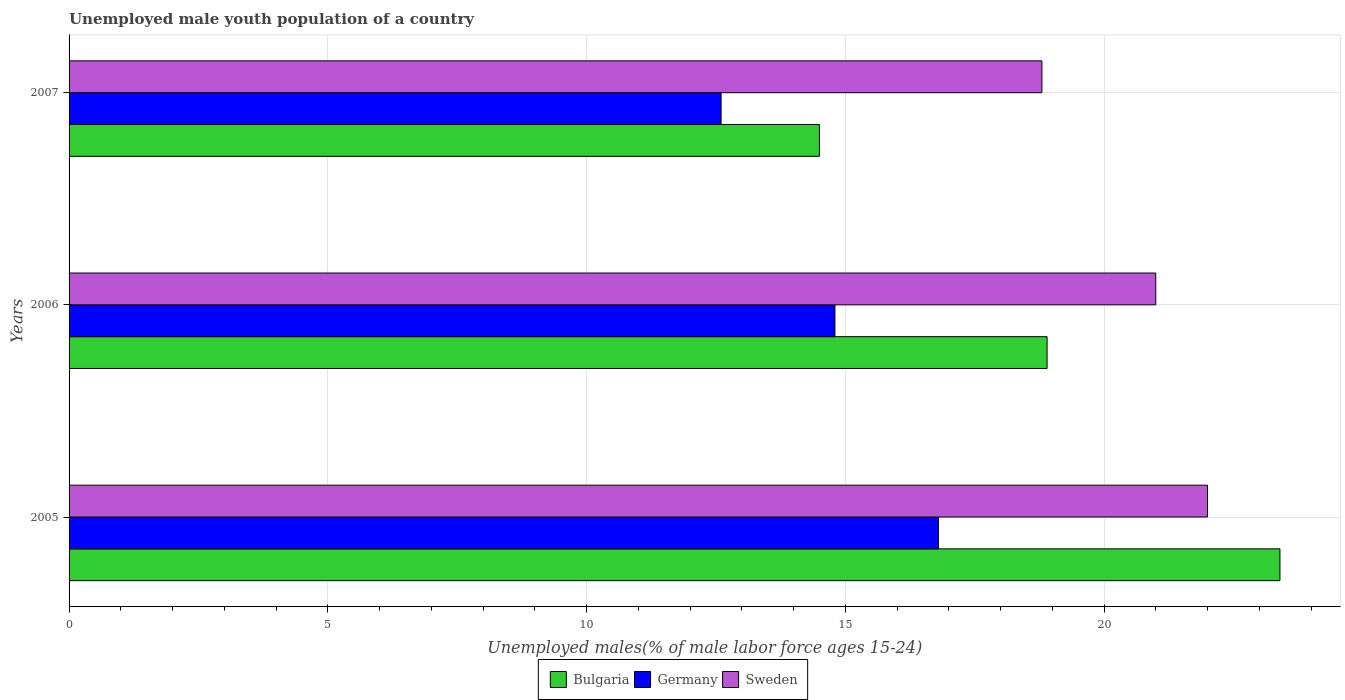How many different coloured bars are there?
Give a very brief answer. 3. How many bars are there on the 1st tick from the bottom?
Your answer should be very brief. 3. What is the label of the 2nd group of bars from the top?
Your answer should be compact. 2006. What is the percentage of unemployed male youth population in Sweden in 2005?
Give a very brief answer. 22. Across all years, what is the maximum percentage of unemployed male youth population in Bulgaria?
Keep it short and to the point. 23.4. Across all years, what is the minimum percentage of unemployed male youth population in Sweden?
Your response must be concise. 18.8. In which year was the percentage of unemployed male youth population in Bulgaria maximum?
Provide a short and direct response. 2005. What is the total percentage of unemployed male youth population in Sweden in the graph?
Keep it short and to the point. 61.8. What is the difference between the percentage of unemployed male youth population in Germany in 2006 and that in 2007?
Provide a succinct answer. 2.2. What is the difference between the percentage of unemployed male youth population in Germany in 2005 and the percentage of unemployed male youth population in Sweden in 2007?
Your answer should be very brief. -2. What is the average percentage of unemployed male youth population in Germany per year?
Offer a terse response. 14.73. In the year 2005, what is the difference between the percentage of unemployed male youth population in Sweden and percentage of unemployed male youth population in Germany?
Provide a short and direct response. 5.2. What is the ratio of the percentage of unemployed male youth population in Sweden in 2006 to that in 2007?
Give a very brief answer. 1.12. Is the difference between the percentage of unemployed male youth population in Sweden in 2005 and 2007 greater than the difference between the percentage of unemployed male youth population in Germany in 2005 and 2007?
Offer a terse response. No. What is the difference between the highest and the second highest percentage of unemployed male youth population in Sweden?
Give a very brief answer. 1. What is the difference between the highest and the lowest percentage of unemployed male youth population in Bulgaria?
Ensure brevity in your answer.  8.9. What does the 3rd bar from the top in 2007 represents?
Provide a succinct answer. Bulgaria. Is it the case that in every year, the sum of the percentage of unemployed male youth population in Germany and percentage of unemployed male youth population in Sweden is greater than the percentage of unemployed male youth population in Bulgaria?
Your response must be concise. Yes. How many bars are there?
Provide a short and direct response. 9. Are all the bars in the graph horizontal?
Keep it short and to the point. Yes. What is the difference between two consecutive major ticks on the X-axis?
Your response must be concise. 5. Does the graph contain any zero values?
Your answer should be compact. No. What is the title of the graph?
Ensure brevity in your answer.  Unemployed male youth population of a country. Does "Hungary" appear as one of the legend labels in the graph?
Ensure brevity in your answer.  No. What is the label or title of the X-axis?
Offer a terse response. Unemployed males(% of male labor force ages 15-24). What is the Unemployed males(% of male labor force ages 15-24) in Bulgaria in 2005?
Keep it short and to the point. 23.4. What is the Unemployed males(% of male labor force ages 15-24) in Germany in 2005?
Provide a succinct answer. 16.8. What is the Unemployed males(% of male labor force ages 15-24) of Bulgaria in 2006?
Provide a short and direct response. 18.9. What is the Unemployed males(% of male labor force ages 15-24) in Germany in 2006?
Offer a terse response. 14.8. What is the Unemployed males(% of male labor force ages 15-24) in Bulgaria in 2007?
Offer a terse response. 14.5. What is the Unemployed males(% of male labor force ages 15-24) in Germany in 2007?
Give a very brief answer. 12.6. What is the Unemployed males(% of male labor force ages 15-24) of Sweden in 2007?
Offer a very short reply. 18.8. Across all years, what is the maximum Unemployed males(% of male labor force ages 15-24) of Bulgaria?
Provide a succinct answer. 23.4. Across all years, what is the maximum Unemployed males(% of male labor force ages 15-24) of Germany?
Your answer should be compact. 16.8. Across all years, what is the minimum Unemployed males(% of male labor force ages 15-24) in Bulgaria?
Ensure brevity in your answer.  14.5. Across all years, what is the minimum Unemployed males(% of male labor force ages 15-24) in Germany?
Your answer should be compact. 12.6. Across all years, what is the minimum Unemployed males(% of male labor force ages 15-24) in Sweden?
Keep it short and to the point. 18.8. What is the total Unemployed males(% of male labor force ages 15-24) of Bulgaria in the graph?
Offer a very short reply. 56.8. What is the total Unemployed males(% of male labor force ages 15-24) in Germany in the graph?
Provide a succinct answer. 44.2. What is the total Unemployed males(% of male labor force ages 15-24) of Sweden in the graph?
Your response must be concise. 61.8. What is the difference between the Unemployed males(% of male labor force ages 15-24) of Germany in 2005 and that in 2007?
Give a very brief answer. 4.2. What is the difference between the Unemployed males(% of male labor force ages 15-24) in Bulgaria in 2005 and the Unemployed males(% of male labor force ages 15-24) in Germany in 2006?
Your answer should be very brief. 8.6. What is the difference between the Unemployed males(% of male labor force ages 15-24) in Bulgaria in 2005 and the Unemployed males(% of male labor force ages 15-24) in Sweden in 2006?
Make the answer very short. 2.4. What is the difference between the Unemployed males(% of male labor force ages 15-24) of Germany in 2005 and the Unemployed males(% of male labor force ages 15-24) of Sweden in 2006?
Provide a short and direct response. -4.2. What is the difference between the Unemployed males(% of male labor force ages 15-24) of Bulgaria in 2005 and the Unemployed males(% of male labor force ages 15-24) of Germany in 2007?
Your answer should be compact. 10.8. What is the difference between the Unemployed males(% of male labor force ages 15-24) in Bulgaria in 2005 and the Unemployed males(% of male labor force ages 15-24) in Sweden in 2007?
Provide a succinct answer. 4.6. What is the difference between the Unemployed males(% of male labor force ages 15-24) in Germany in 2005 and the Unemployed males(% of male labor force ages 15-24) in Sweden in 2007?
Provide a short and direct response. -2. What is the difference between the Unemployed males(% of male labor force ages 15-24) of Bulgaria in 2006 and the Unemployed males(% of male labor force ages 15-24) of Germany in 2007?
Provide a succinct answer. 6.3. What is the average Unemployed males(% of male labor force ages 15-24) of Bulgaria per year?
Your response must be concise. 18.93. What is the average Unemployed males(% of male labor force ages 15-24) of Germany per year?
Offer a very short reply. 14.73. What is the average Unemployed males(% of male labor force ages 15-24) of Sweden per year?
Your answer should be compact. 20.6. In the year 2005, what is the difference between the Unemployed males(% of male labor force ages 15-24) in Germany and Unemployed males(% of male labor force ages 15-24) in Sweden?
Make the answer very short. -5.2. In the year 2006, what is the difference between the Unemployed males(% of male labor force ages 15-24) of Bulgaria and Unemployed males(% of male labor force ages 15-24) of Sweden?
Offer a terse response. -2.1. In the year 2006, what is the difference between the Unemployed males(% of male labor force ages 15-24) of Germany and Unemployed males(% of male labor force ages 15-24) of Sweden?
Your response must be concise. -6.2. In the year 2007, what is the difference between the Unemployed males(% of male labor force ages 15-24) of Bulgaria and Unemployed males(% of male labor force ages 15-24) of Germany?
Keep it short and to the point. 1.9. In the year 2007, what is the difference between the Unemployed males(% of male labor force ages 15-24) in Germany and Unemployed males(% of male labor force ages 15-24) in Sweden?
Offer a very short reply. -6.2. What is the ratio of the Unemployed males(% of male labor force ages 15-24) in Bulgaria in 2005 to that in 2006?
Provide a succinct answer. 1.24. What is the ratio of the Unemployed males(% of male labor force ages 15-24) of Germany in 2005 to that in 2006?
Make the answer very short. 1.14. What is the ratio of the Unemployed males(% of male labor force ages 15-24) of Sweden in 2005 to that in 2006?
Keep it short and to the point. 1.05. What is the ratio of the Unemployed males(% of male labor force ages 15-24) of Bulgaria in 2005 to that in 2007?
Provide a short and direct response. 1.61. What is the ratio of the Unemployed males(% of male labor force ages 15-24) in Sweden in 2005 to that in 2007?
Give a very brief answer. 1.17. What is the ratio of the Unemployed males(% of male labor force ages 15-24) of Bulgaria in 2006 to that in 2007?
Your response must be concise. 1.3. What is the ratio of the Unemployed males(% of male labor force ages 15-24) of Germany in 2006 to that in 2007?
Your response must be concise. 1.17. What is the ratio of the Unemployed males(% of male labor force ages 15-24) in Sweden in 2006 to that in 2007?
Offer a terse response. 1.12. What is the difference between the highest and the second highest Unemployed males(% of male labor force ages 15-24) in Sweden?
Your response must be concise. 1. What is the difference between the highest and the lowest Unemployed males(% of male labor force ages 15-24) of Germany?
Your response must be concise. 4.2. What is the difference between the highest and the lowest Unemployed males(% of male labor force ages 15-24) in Sweden?
Keep it short and to the point. 3.2. 